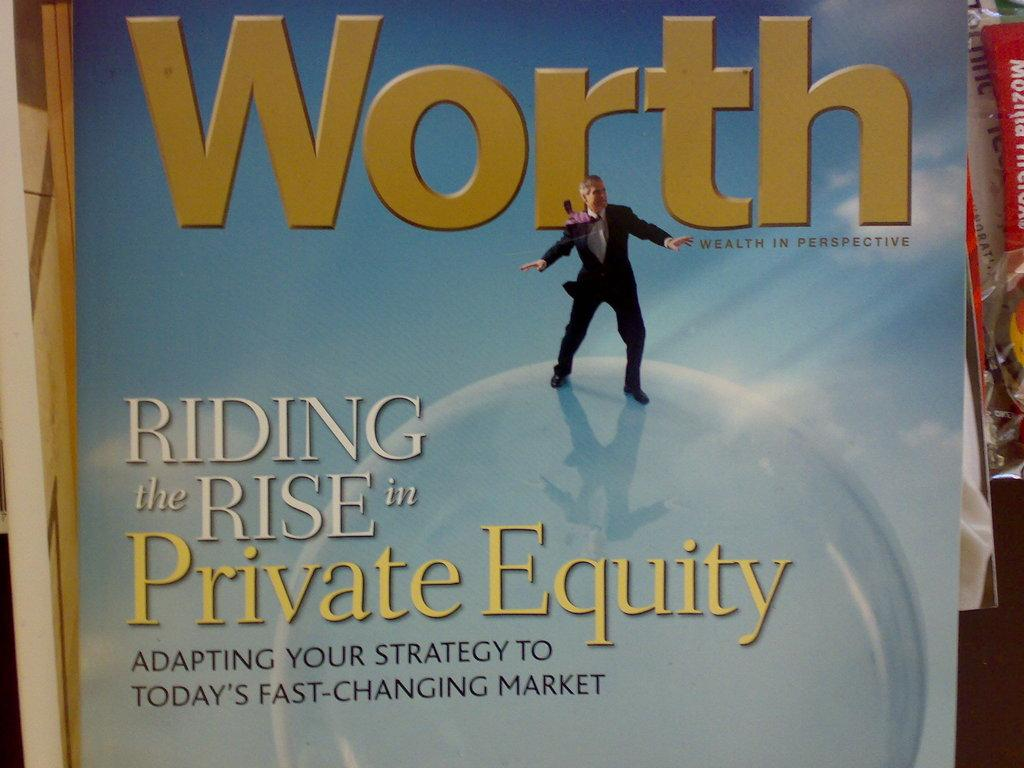<image>
Offer a succinct explanation of the picture presented. An issue of Worth magazine discusses private equity. 